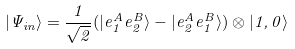<formula> <loc_0><loc_0><loc_500><loc_500>| \Psi _ { i n } \rangle = \frac { 1 } { \sqrt { 2 } } ( | e _ { 1 } ^ { A } e _ { 2 } ^ { B } \rangle - | e _ { 2 } ^ { A } e _ { 1 } ^ { B } \rangle ) \otimes | 1 , 0 \rangle</formula> 